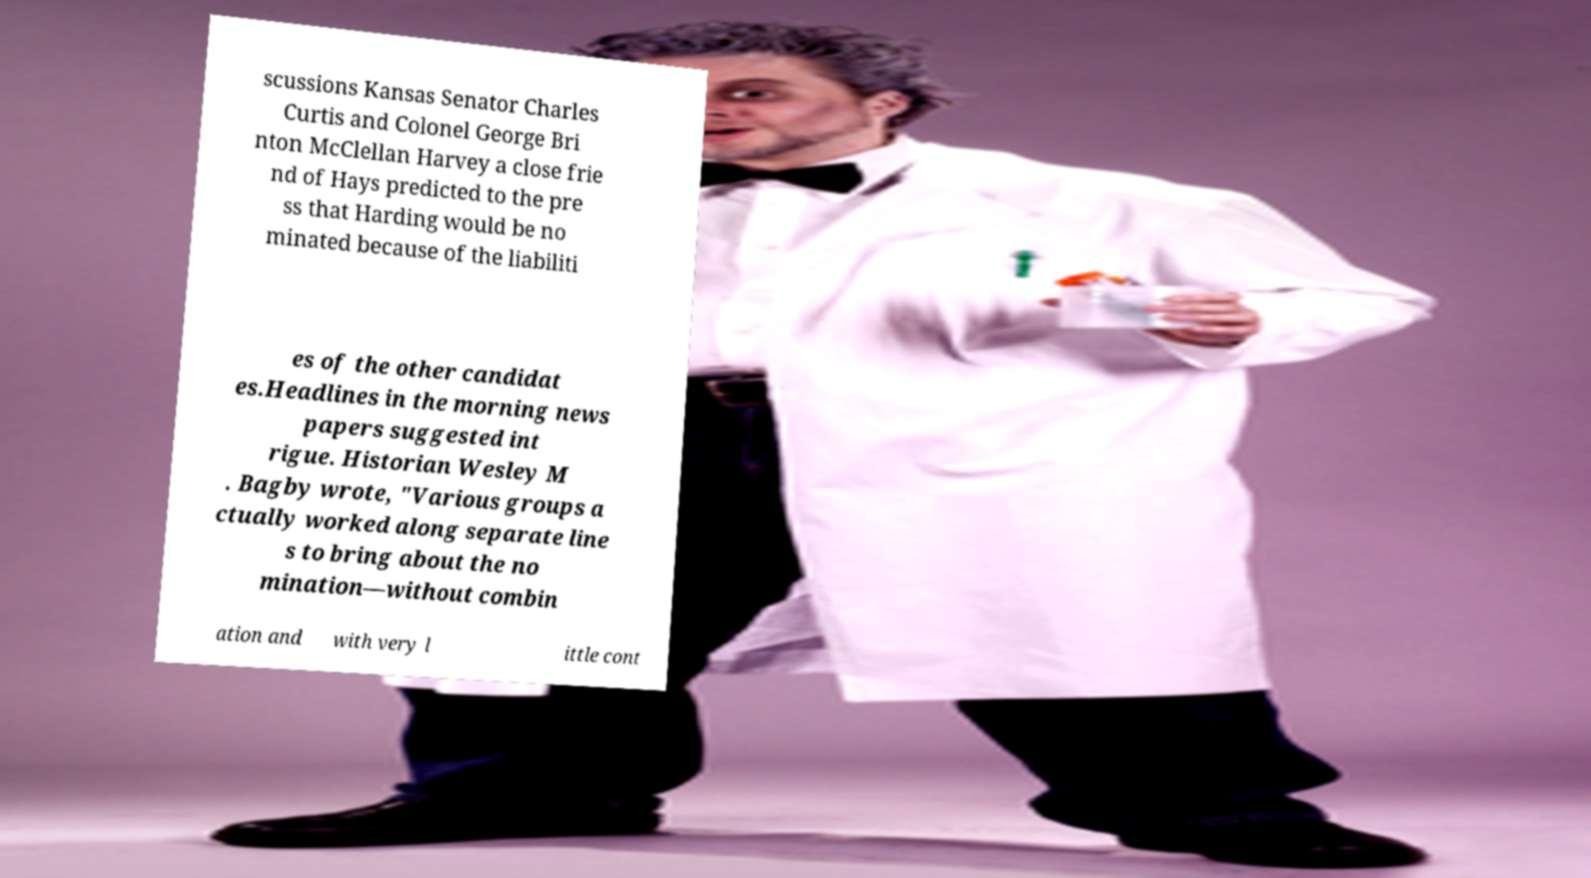For documentation purposes, I need the text within this image transcribed. Could you provide that? scussions Kansas Senator Charles Curtis and Colonel George Bri nton McClellan Harvey a close frie nd of Hays predicted to the pre ss that Harding would be no minated because of the liabiliti es of the other candidat es.Headlines in the morning news papers suggested int rigue. Historian Wesley M . Bagby wrote, "Various groups a ctually worked along separate line s to bring about the no mination—without combin ation and with very l ittle cont 